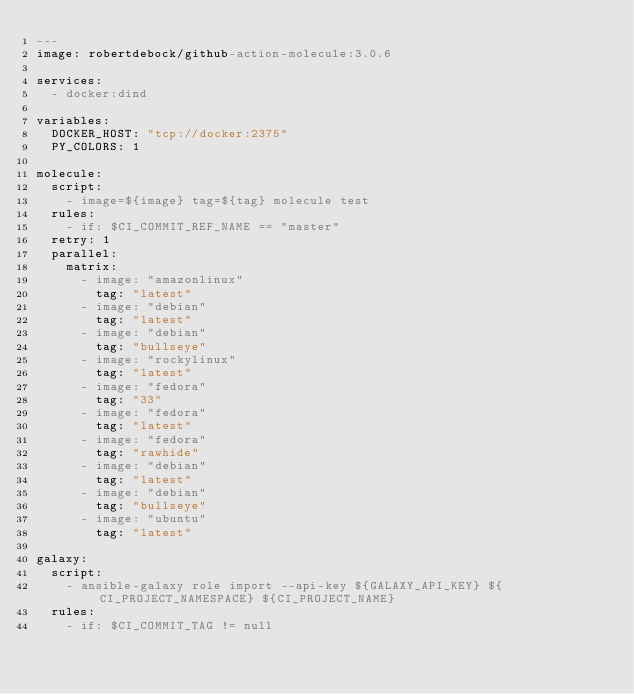Convert code to text. <code><loc_0><loc_0><loc_500><loc_500><_YAML_>---
image: robertdebock/github-action-molecule:3.0.6

services:
  - docker:dind

variables:
  DOCKER_HOST: "tcp://docker:2375"
  PY_COLORS: 1

molecule:
  script:
    - image=${image} tag=${tag} molecule test
  rules:
    - if: $CI_COMMIT_REF_NAME == "master"
  retry: 1
  parallel:
    matrix:
      - image: "amazonlinux"
        tag: "latest"
      - image: "debian"
        tag: "latest"
      - image: "debian"
        tag: "bullseye"
      - image: "rockylinux"
        tag: "latest"
      - image: "fedora"
        tag: "33"
      - image: "fedora"
        tag: "latest"
      - image: "fedora"
        tag: "rawhide"
      - image: "debian"
        tag: "latest"
      - image: "debian"
        tag: "bullseye"
      - image: "ubuntu"
        tag: "latest"

galaxy:
  script:
    - ansible-galaxy role import --api-key ${GALAXY_API_KEY} ${CI_PROJECT_NAMESPACE} ${CI_PROJECT_NAME}
  rules:
    - if: $CI_COMMIT_TAG != null
</code> 